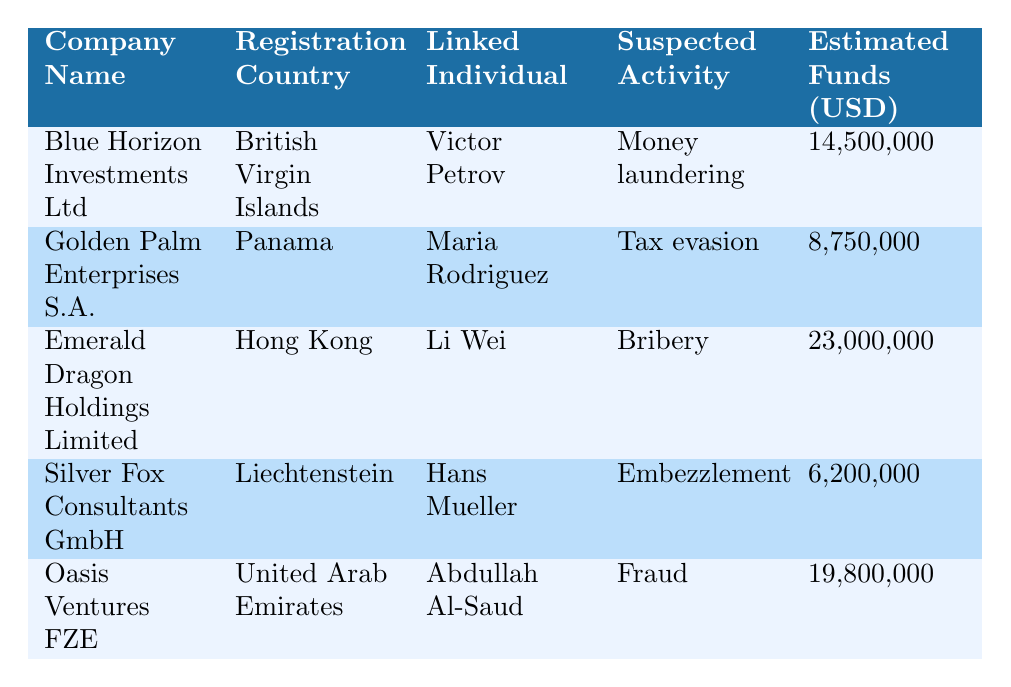What is the registration country of Blue Horizon Investments Ltd? The table lists the registration country of Blue Horizon Investments Ltd as "British Virgin Islands".
Answer: British Virgin Islands Who is the linked individual for Oasis Ventures FZE? The table indicates that the linked individual for Oasis Ventures FZE is "Abdullah Al-Saud".
Answer: Abdullah Al-Saud What is the estimated funds transferred for Emerald Dragon Holdings Limited? According to the table, the estimated funds transferred for Emerald Dragon Holdings Limited is 23,000,000 USD.
Answer: 23,000,000 USD Which company has the highest estimated funds transferred? By comparing the values in the "Estimated Funds" column, Emerald Dragon Holdings Limited has the highest estimated funds transferred at 23,000,000 USD.
Answer: Emerald Dragon Holdings Limited Is Silver Fox Consultants GmbH linked to tax evasion? The table shows that Silver Fox Consultants GmbH is linked to "Embezzlement", not tax evasion.
Answer: No What was the average estimated funds transferred for all companies listed? To find the average, sum the estimated funds: 14,500,000 + 8,750,000 + 23,000,000 + 6,200,000 + 19,800,000 = 72,250,000. Since there are 5 companies, the average is 72,250,000 / 5 = 14,450,000 USD.
Answer: 14,450,000 USD Which registration country has the least number of linked shell companies in the table? The table lists one company for each registration country, so all registration countries (British Virgin Islands, Panama, Hong Kong, Liechtenstein, and United Arab Emirates) have the same count of one.
Answer: All have one company What type of suspected illicit activity is linked to Golden Palm Enterprises S.A.? The table specifies that Golden Palm Enterprises S.A. is linked to "Tax evasion".
Answer: Tax evasion How many companies are linked to bank accounts in UBS AG? The table shows that only Blue Horizon Investments Ltd is linked to bank accounts in UBS AG, as indicated in the "Bank Accounts" column.
Answer: One company Is there any company linked to bribery that has been registered in the last five years? Looking at the registration years, Emerald Dragon Holdings Limited, linked to bribery, was incorporated in 2014, which does not fall within the last five years (2018 or later). Therefore, no companies linked to bribery have been registered in the last five years.
Answer: No 